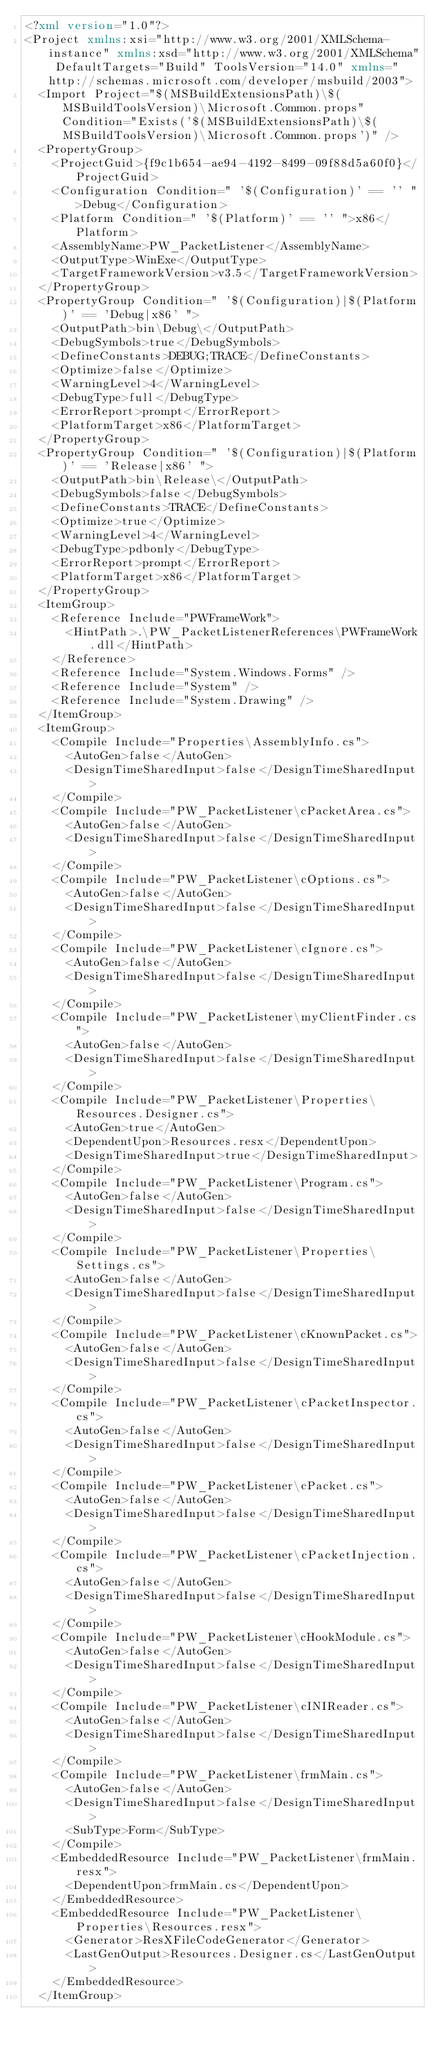<code> <loc_0><loc_0><loc_500><loc_500><_XML_><?xml version="1.0"?>
<Project xmlns:xsi="http://www.w3.org/2001/XMLSchema-instance" xmlns:xsd="http://www.w3.org/2001/XMLSchema" DefaultTargets="Build" ToolsVersion="14.0" xmlns="http://schemas.microsoft.com/developer/msbuild/2003">
  <Import Project="$(MSBuildExtensionsPath)\$(MSBuildToolsVersion)\Microsoft.Common.props" Condition="Exists('$(MSBuildExtensionsPath)\$(MSBuildToolsVersion)\Microsoft.Common.props')" />
  <PropertyGroup>
    <ProjectGuid>{f9c1b654-ae94-4192-8499-09f88d5a60f0}</ProjectGuid>
    <Configuration Condition=" '$(Configuration)' == '' ">Debug</Configuration>
    <Platform Condition=" '$(Platform)' == '' ">x86</Platform>
    <AssemblyName>PW_PacketListener</AssemblyName>
    <OutputType>WinExe</OutputType>
    <TargetFrameworkVersion>v3.5</TargetFrameworkVersion>
  </PropertyGroup>
  <PropertyGroup Condition=" '$(Configuration)|$(Platform)' == 'Debug|x86' ">
    <OutputPath>bin\Debug\</OutputPath>
    <DebugSymbols>true</DebugSymbols>
    <DefineConstants>DEBUG;TRACE</DefineConstants>
    <Optimize>false</Optimize>
    <WarningLevel>4</WarningLevel>
    <DebugType>full</DebugType>
    <ErrorReport>prompt</ErrorReport>
    <PlatformTarget>x86</PlatformTarget>
  </PropertyGroup>
  <PropertyGroup Condition=" '$(Configuration)|$(Platform)' == 'Release|x86' ">
    <OutputPath>bin\Release\</OutputPath>
    <DebugSymbols>false</DebugSymbols>
    <DefineConstants>TRACE</DefineConstants>
    <Optimize>true</Optimize>
    <WarningLevel>4</WarningLevel>
    <DebugType>pdbonly</DebugType>
    <ErrorReport>prompt</ErrorReport>
    <PlatformTarget>x86</PlatformTarget>
  </PropertyGroup>
  <ItemGroup>
    <Reference Include="PWFrameWork">
      <HintPath>.\PW_PacketListenerReferences\PWFrameWork.dll</HintPath>
    </Reference>
    <Reference Include="System.Windows.Forms" />
    <Reference Include="System" />
    <Reference Include="System.Drawing" />
  </ItemGroup>
  <ItemGroup>
    <Compile Include="Properties\AssemblyInfo.cs">
      <AutoGen>false</AutoGen>
      <DesignTimeSharedInput>false</DesignTimeSharedInput>
    </Compile>
    <Compile Include="PW_PacketListener\cPacketArea.cs">
      <AutoGen>false</AutoGen>
      <DesignTimeSharedInput>false</DesignTimeSharedInput>
    </Compile>
    <Compile Include="PW_PacketListener\cOptions.cs">
      <AutoGen>false</AutoGen>
      <DesignTimeSharedInput>false</DesignTimeSharedInput>
    </Compile>
    <Compile Include="PW_PacketListener\cIgnore.cs">
      <AutoGen>false</AutoGen>
      <DesignTimeSharedInput>false</DesignTimeSharedInput>
    </Compile>
    <Compile Include="PW_PacketListener\myClientFinder.cs">
      <AutoGen>false</AutoGen>
      <DesignTimeSharedInput>false</DesignTimeSharedInput>
    </Compile>
    <Compile Include="PW_PacketListener\Properties\Resources.Designer.cs">
      <AutoGen>true</AutoGen>
      <DependentUpon>Resources.resx</DependentUpon>
      <DesignTimeSharedInput>true</DesignTimeSharedInput>
    </Compile>
    <Compile Include="PW_PacketListener\Program.cs">
      <AutoGen>false</AutoGen>
      <DesignTimeSharedInput>false</DesignTimeSharedInput>
    </Compile>
    <Compile Include="PW_PacketListener\Properties\Settings.cs">
      <AutoGen>false</AutoGen>
      <DesignTimeSharedInput>false</DesignTimeSharedInput>
    </Compile>
    <Compile Include="PW_PacketListener\cKnownPacket.cs">
      <AutoGen>false</AutoGen>
      <DesignTimeSharedInput>false</DesignTimeSharedInput>
    </Compile>
    <Compile Include="PW_PacketListener\cPacketInspector.cs">
      <AutoGen>false</AutoGen>
      <DesignTimeSharedInput>false</DesignTimeSharedInput>
    </Compile>
    <Compile Include="PW_PacketListener\cPacket.cs">
      <AutoGen>false</AutoGen>
      <DesignTimeSharedInput>false</DesignTimeSharedInput>
    </Compile>
    <Compile Include="PW_PacketListener\cPacketInjection.cs">
      <AutoGen>false</AutoGen>
      <DesignTimeSharedInput>false</DesignTimeSharedInput>
    </Compile>
    <Compile Include="PW_PacketListener\cHookModule.cs">
      <AutoGen>false</AutoGen>
      <DesignTimeSharedInput>false</DesignTimeSharedInput>
    </Compile>
    <Compile Include="PW_PacketListener\cINIReader.cs">
      <AutoGen>false</AutoGen>
      <DesignTimeSharedInput>false</DesignTimeSharedInput>
    </Compile>
    <Compile Include="PW_PacketListener\frmMain.cs">
      <AutoGen>false</AutoGen>
      <DesignTimeSharedInput>false</DesignTimeSharedInput>
      <SubType>Form</SubType>
    </Compile>
    <EmbeddedResource Include="PW_PacketListener\frmMain.resx">
      <DependentUpon>frmMain.cs</DependentUpon>
    </EmbeddedResource>
    <EmbeddedResource Include="PW_PacketListener\Properties\Resources.resx">
      <Generator>ResXFileCodeGenerator</Generator>
      <LastGenOutput>Resources.Designer.cs</LastGenOutput>
    </EmbeddedResource>
  </ItemGroup></code> 